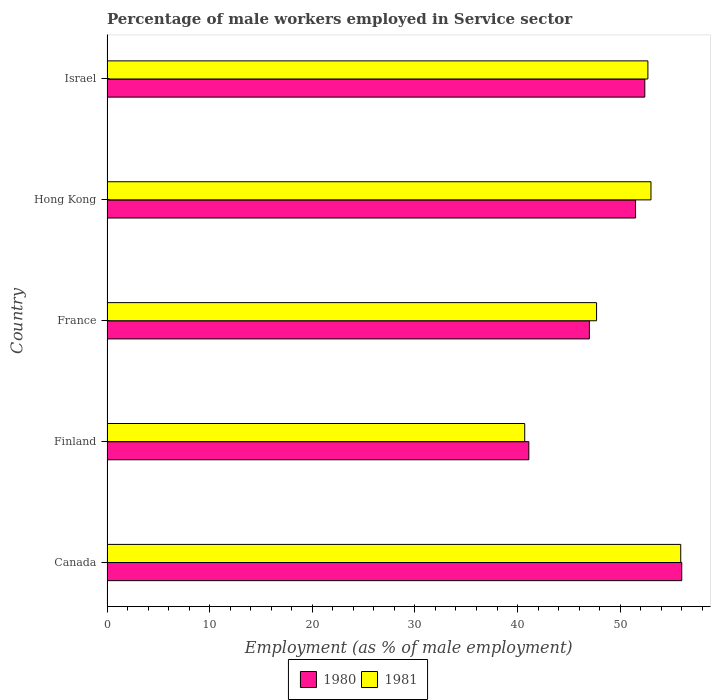How many different coloured bars are there?
Give a very brief answer. 2. How many groups of bars are there?
Make the answer very short. 5. Are the number of bars on each tick of the Y-axis equal?
Provide a short and direct response. Yes. What is the label of the 4th group of bars from the top?
Offer a very short reply. Finland. In how many cases, is the number of bars for a given country not equal to the number of legend labels?
Provide a succinct answer. 0. What is the percentage of male workers employed in Service sector in 1981 in Canada?
Provide a short and direct response. 55.9. Across all countries, what is the minimum percentage of male workers employed in Service sector in 1981?
Offer a very short reply. 40.7. In which country was the percentage of male workers employed in Service sector in 1981 minimum?
Ensure brevity in your answer.  Finland. What is the total percentage of male workers employed in Service sector in 1981 in the graph?
Keep it short and to the point. 250. What is the difference between the percentage of male workers employed in Service sector in 1981 in Hong Kong and that in Israel?
Ensure brevity in your answer.  0.3. What is the difference between the percentage of male workers employed in Service sector in 1980 in Canada and the percentage of male workers employed in Service sector in 1981 in France?
Make the answer very short. 8.3. What is the average percentage of male workers employed in Service sector in 1981 per country?
Provide a succinct answer. 50. What is the difference between the percentage of male workers employed in Service sector in 1980 and percentage of male workers employed in Service sector in 1981 in France?
Your response must be concise. -0.7. In how many countries, is the percentage of male workers employed in Service sector in 1981 greater than 30 %?
Provide a succinct answer. 5. What is the ratio of the percentage of male workers employed in Service sector in 1981 in Canada to that in France?
Ensure brevity in your answer.  1.17. Is the percentage of male workers employed in Service sector in 1981 in Canada less than that in Hong Kong?
Give a very brief answer. No. Is the difference between the percentage of male workers employed in Service sector in 1980 in Finland and Hong Kong greater than the difference between the percentage of male workers employed in Service sector in 1981 in Finland and Hong Kong?
Provide a short and direct response. Yes. What is the difference between the highest and the second highest percentage of male workers employed in Service sector in 1981?
Ensure brevity in your answer.  2.9. What is the difference between the highest and the lowest percentage of male workers employed in Service sector in 1981?
Provide a short and direct response. 15.2. Are the values on the major ticks of X-axis written in scientific E-notation?
Provide a succinct answer. No. Does the graph contain any zero values?
Ensure brevity in your answer.  No. What is the title of the graph?
Make the answer very short. Percentage of male workers employed in Service sector. What is the label or title of the X-axis?
Offer a terse response. Employment (as % of male employment). What is the Employment (as % of male employment) of 1981 in Canada?
Offer a terse response. 55.9. What is the Employment (as % of male employment) in 1980 in Finland?
Offer a terse response. 41.1. What is the Employment (as % of male employment) of 1981 in Finland?
Your answer should be compact. 40.7. What is the Employment (as % of male employment) in 1981 in France?
Provide a succinct answer. 47.7. What is the Employment (as % of male employment) of 1980 in Hong Kong?
Your answer should be compact. 51.5. What is the Employment (as % of male employment) of 1980 in Israel?
Make the answer very short. 52.4. What is the Employment (as % of male employment) of 1981 in Israel?
Keep it short and to the point. 52.7. Across all countries, what is the maximum Employment (as % of male employment) in 1980?
Make the answer very short. 56. Across all countries, what is the maximum Employment (as % of male employment) in 1981?
Ensure brevity in your answer.  55.9. Across all countries, what is the minimum Employment (as % of male employment) of 1980?
Your answer should be very brief. 41.1. Across all countries, what is the minimum Employment (as % of male employment) in 1981?
Provide a short and direct response. 40.7. What is the total Employment (as % of male employment) of 1980 in the graph?
Offer a very short reply. 248. What is the total Employment (as % of male employment) of 1981 in the graph?
Provide a short and direct response. 250. What is the difference between the Employment (as % of male employment) of 1980 in Canada and that in Finland?
Keep it short and to the point. 14.9. What is the difference between the Employment (as % of male employment) of 1980 in Canada and that in France?
Your response must be concise. 9. What is the difference between the Employment (as % of male employment) of 1980 in Canada and that in Hong Kong?
Your answer should be very brief. 4.5. What is the difference between the Employment (as % of male employment) in 1981 in Canada and that in Hong Kong?
Provide a succinct answer. 2.9. What is the difference between the Employment (as % of male employment) of 1980 in Canada and that in Israel?
Give a very brief answer. 3.6. What is the difference between the Employment (as % of male employment) of 1981 in Finland and that in France?
Offer a terse response. -7. What is the difference between the Employment (as % of male employment) in 1981 in Finland and that in Hong Kong?
Your answer should be compact. -12.3. What is the difference between the Employment (as % of male employment) of 1980 in Finland and that in Israel?
Your response must be concise. -11.3. What is the difference between the Employment (as % of male employment) of 1981 in Finland and that in Israel?
Your answer should be very brief. -12. What is the difference between the Employment (as % of male employment) in 1980 in France and that in Hong Kong?
Ensure brevity in your answer.  -4.5. What is the difference between the Employment (as % of male employment) in 1981 in France and that in Hong Kong?
Keep it short and to the point. -5.3. What is the difference between the Employment (as % of male employment) of 1980 in Canada and the Employment (as % of male employment) of 1981 in Finland?
Provide a succinct answer. 15.3. What is the difference between the Employment (as % of male employment) of 1980 in Canada and the Employment (as % of male employment) of 1981 in France?
Make the answer very short. 8.3. What is the difference between the Employment (as % of male employment) of 1980 in Canada and the Employment (as % of male employment) of 1981 in Israel?
Offer a very short reply. 3.3. What is the difference between the Employment (as % of male employment) in 1980 in Finland and the Employment (as % of male employment) in 1981 in France?
Keep it short and to the point. -6.6. What is the difference between the Employment (as % of male employment) in 1980 in Hong Kong and the Employment (as % of male employment) in 1981 in Israel?
Offer a very short reply. -1.2. What is the average Employment (as % of male employment) in 1980 per country?
Make the answer very short. 49.6. What is the difference between the Employment (as % of male employment) of 1980 and Employment (as % of male employment) of 1981 in Hong Kong?
Make the answer very short. -1.5. What is the ratio of the Employment (as % of male employment) in 1980 in Canada to that in Finland?
Provide a succinct answer. 1.36. What is the ratio of the Employment (as % of male employment) in 1981 in Canada to that in Finland?
Make the answer very short. 1.37. What is the ratio of the Employment (as % of male employment) of 1980 in Canada to that in France?
Offer a terse response. 1.19. What is the ratio of the Employment (as % of male employment) in 1981 in Canada to that in France?
Your response must be concise. 1.17. What is the ratio of the Employment (as % of male employment) of 1980 in Canada to that in Hong Kong?
Offer a very short reply. 1.09. What is the ratio of the Employment (as % of male employment) in 1981 in Canada to that in Hong Kong?
Your response must be concise. 1.05. What is the ratio of the Employment (as % of male employment) of 1980 in Canada to that in Israel?
Ensure brevity in your answer.  1.07. What is the ratio of the Employment (as % of male employment) in 1981 in Canada to that in Israel?
Provide a short and direct response. 1.06. What is the ratio of the Employment (as % of male employment) of 1980 in Finland to that in France?
Keep it short and to the point. 0.87. What is the ratio of the Employment (as % of male employment) of 1981 in Finland to that in France?
Provide a short and direct response. 0.85. What is the ratio of the Employment (as % of male employment) in 1980 in Finland to that in Hong Kong?
Your answer should be very brief. 0.8. What is the ratio of the Employment (as % of male employment) of 1981 in Finland to that in Hong Kong?
Your answer should be very brief. 0.77. What is the ratio of the Employment (as % of male employment) in 1980 in Finland to that in Israel?
Ensure brevity in your answer.  0.78. What is the ratio of the Employment (as % of male employment) of 1981 in Finland to that in Israel?
Your answer should be compact. 0.77. What is the ratio of the Employment (as % of male employment) of 1980 in France to that in Hong Kong?
Your answer should be very brief. 0.91. What is the ratio of the Employment (as % of male employment) of 1981 in France to that in Hong Kong?
Give a very brief answer. 0.9. What is the ratio of the Employment (as % of male employment) of 1980 in France to that in Israel?
Your answer should be compact. 0.9. What is the ratio of the Employment (as % of male employment) in 1981 in France to that in Israel?
Make the answer very short. 0.91. What is the ratio of the Employment (as % of male employment) of 1980 in Hong Kong to that in Israel?
Make the answer very short. 0.98. What is the difference between the highest and the second highest Employment (as % of male employment) of 1981?
Give a very brief answer. 2.9. What is the difference between the highest and the lowest Employment (as % of male employment) in 1981?
Make the answer very short. 15.2. 